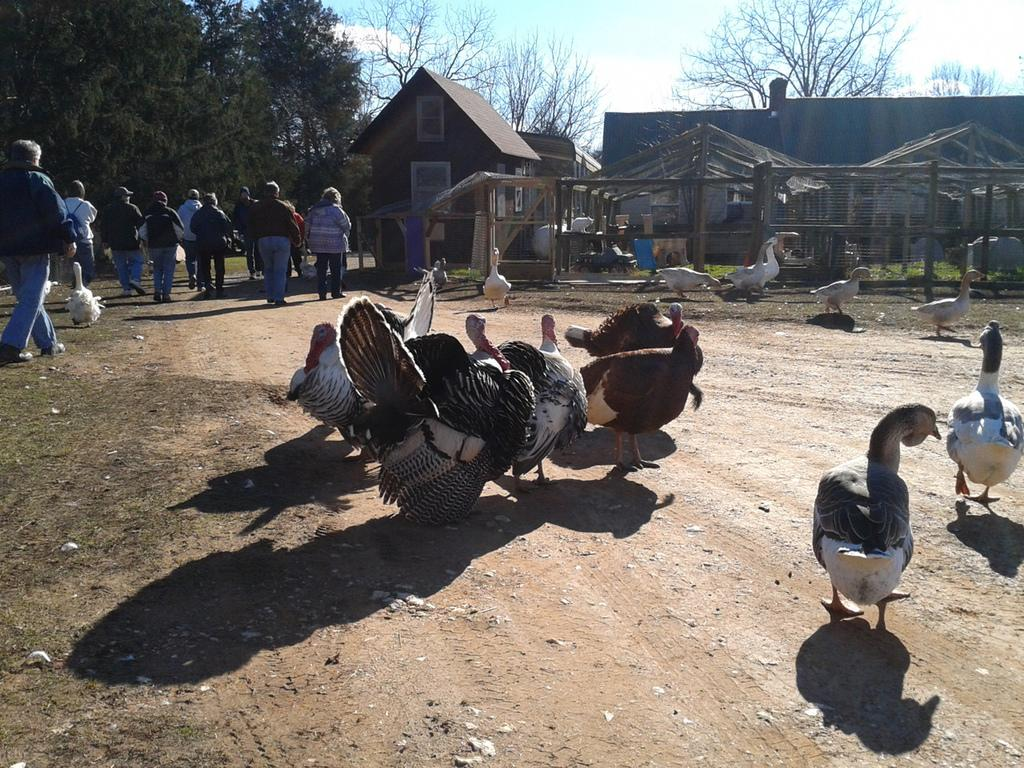What type of animals can be seen in the image? There are birds in the image. What are the people in the image doing? People are walking on the road in the image. What can be seen in the background of the image? There are buildings, sheds, trees, and the sky visible in the background of the image. What type of square can be seen in the image? There is no square present in the image. How does the wave affect the birds in the image? There is no wave present in the image, so it does not affect the birds. 